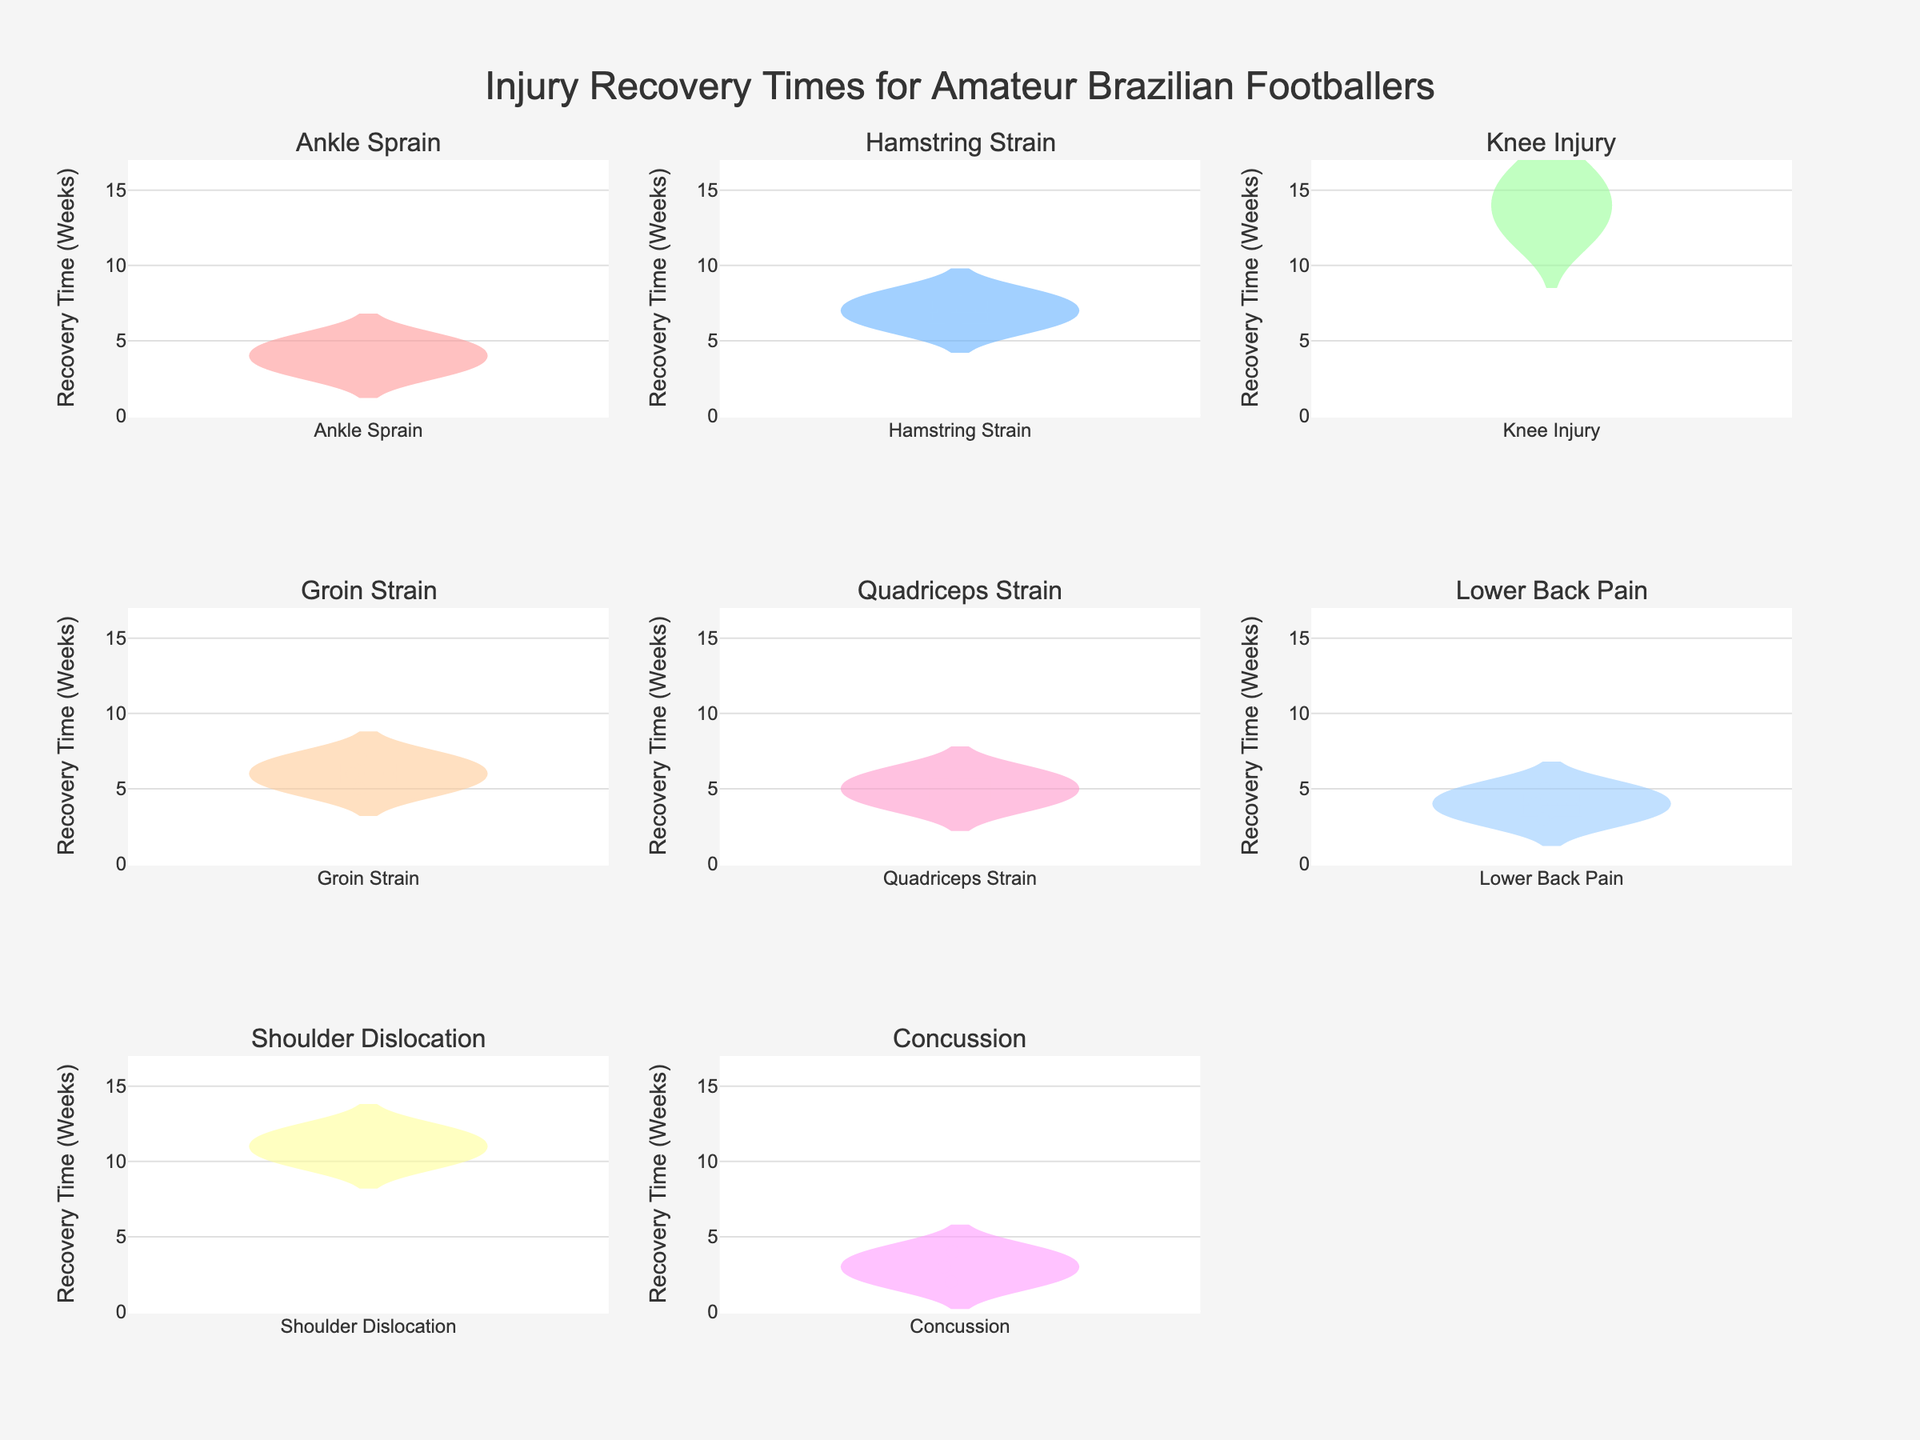What's the range of recovery times for "Ankle Sprain"? The range is determined by the difference between the maximum and minimum recovery times for Ankle Sprain. From the plot, we see the minimum is 3 weeks and the maximum is 5 weeks. Hence, the range is 5 - 3 = 2 weeks.
Answer: 2 weeks Which injury type has the longest median recovery time? By looking at the median lines in each subplot, it is clear that "Knee Injury" has the longest median recovery time, which lies around 14 weeks.
Answer: Knee Injury How do the recovery times for "Groin Strain" compare to those for "Ankle Sprain"? "Groin Strain" recovery times are generally higher, ranging from 5 to 7 weeks, compared to "Ankle Sprain" which ranges from 3 to 5 weeks. This indicates that "Groin Strain" recovery times are slightly longer on average.
Answer: Groin Strain is longer What's the mean recovery time for "Concussion"? Locate the median line's mean marker in the "Concussion" subplot; it is around 3 weeks. The exact mean can be found by calculating the average of 2, 3, and 4, which is (2+3+4)/3 = 3 weeks.
Answer: 3 weeks For which injury type is the data most spread out? This can be observed by noting the width of the violin plot. "Knee Injury" has the most spread-out data, with recovery times ranging from 12 to 16 weeks.
Answer: Knee Injury What is the interquartile range for "Hamstring Strain"? The interquartile range (IQR) is the range between the first quartile (Q1) and the third quartile (Q3). For "Hamstring Strain", this appears to be from about 6 to 8 weeks, so the IQR is 8 - 6 = 2 weeks.
Answer: 2 weeks Which injury types have the most similar recovery time distributions? "Quadriceps Strain" and "Lower Back Pain" have similar distributions since their violin plots both show a range of 3 to 6 weeks with similar shapes and spreads.
Answer: Quadriceps Strain and Lower Back Pain Are there any outliers in the "Shoulder Dislocation" recovery times? Outliers can be seen as points outside the main body of the violin plot. In the "Shoulder Dislocation" subplot, all data points (10, 11, 12 weeks) lie close to the body of the plot, indicating no significant outliers.
Answer: No What is the mode recovery time for "Lower Back Pain"? The mode is the most frequently occurring value. In the case of "Lower Back Pain", the recovery times (3, 4, 5 weeks) are evenly distributed, suggesting no mode or multiple modes.
Answer: No mode Which injury type requires the least recovery time? By examining the maximum lower extent of each violin plot, "Concussion" has the least recovery time, with a minimum of 2 weeks.
Answer: Concussion 